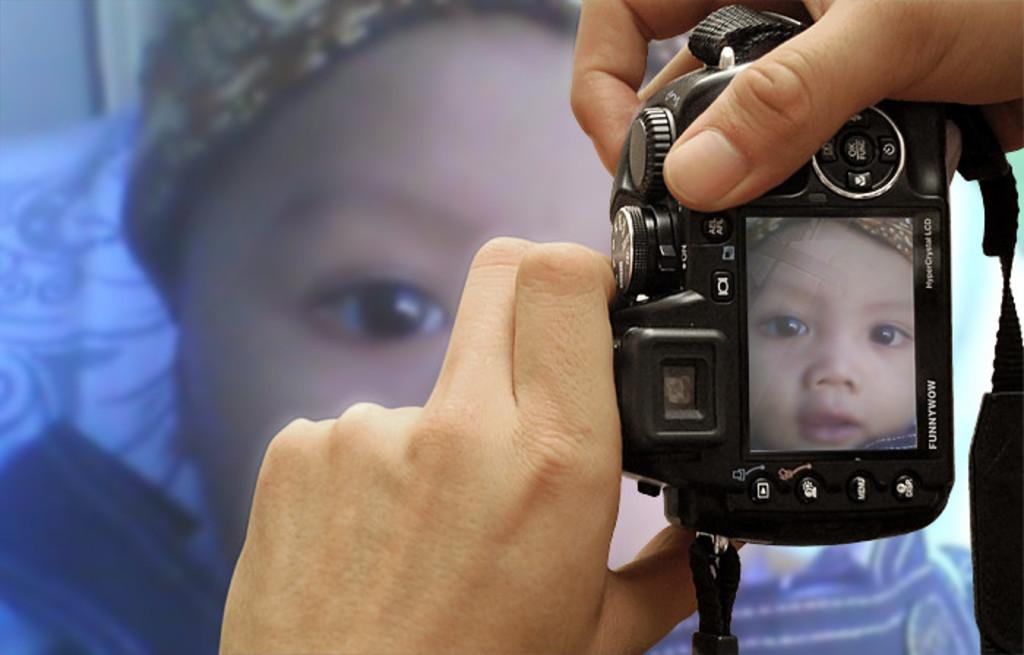Who is the main subject in the image? There is a person in the image. What is the person holding in the image? The person is holding a camera. What is the purpose of the camera in the image? The camera is being used to capture an image of a baby. Can you confirm the presence of the baby in the image? Yes, the baby is present in the image. What type of steel is being used to support the judge's bench in the image? There is no judge's bench or steel present in the image; it features a person holding a camera and a baby. 